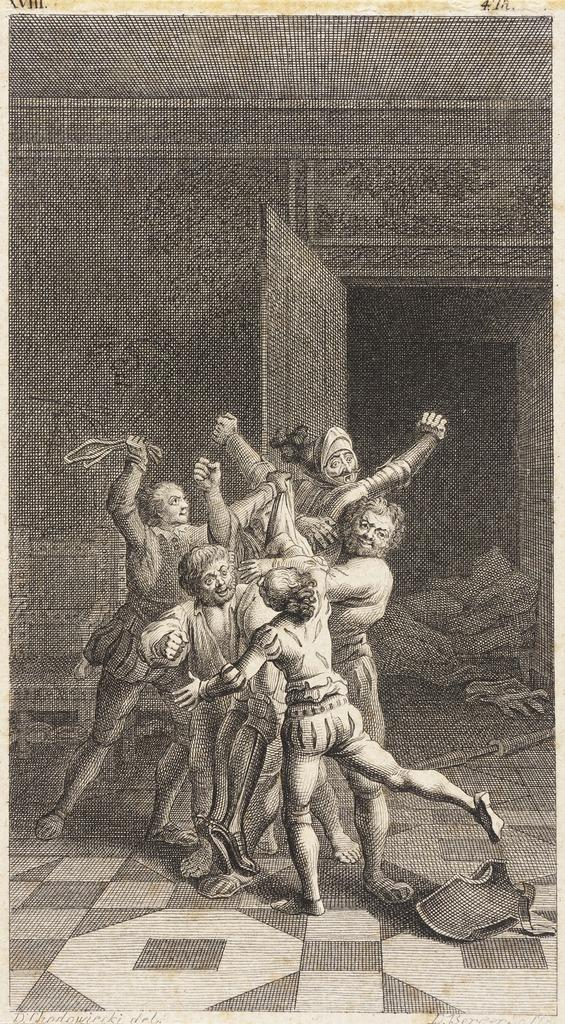What is the main subject of the poster in the image? The poster contains pictures of people. What type of setting is depicted in the poster? The poster shows a floor, a wall, and a door, suggesting an indoor setting. Are there any objects present in the poster? Yes, the poster includes a few objects. How many trains can be seen passing through the stem in the image? There are no trains or stems present in the image; it features a poster with pictures of people in an indoor setting. 